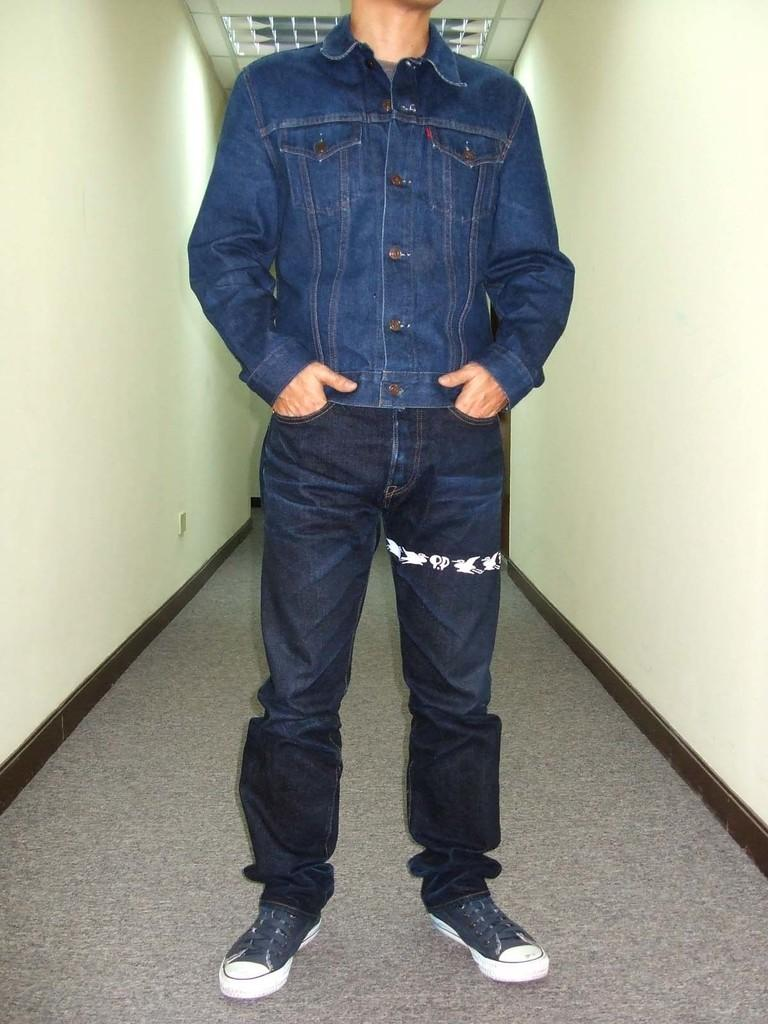What is the main subject in the foreground of the image? There is a person standing in the foreground of the image. What is the person standing on? The person is standing on the floor. What can be seen on the left side of the image? There is a well on the left side of the image. What can be seen on the right side of the image? There is a well on the right side of the image. What is the source of light visible in the image? There is light visible near the ceiling. What type of note is the person holding in the image? There is no note visible in the image; the person is not holding anything. What is the person cooking on the stove in the image? There is no stove present in the image. How many eggs are visible in the image? There are no eggs visible in the image. 